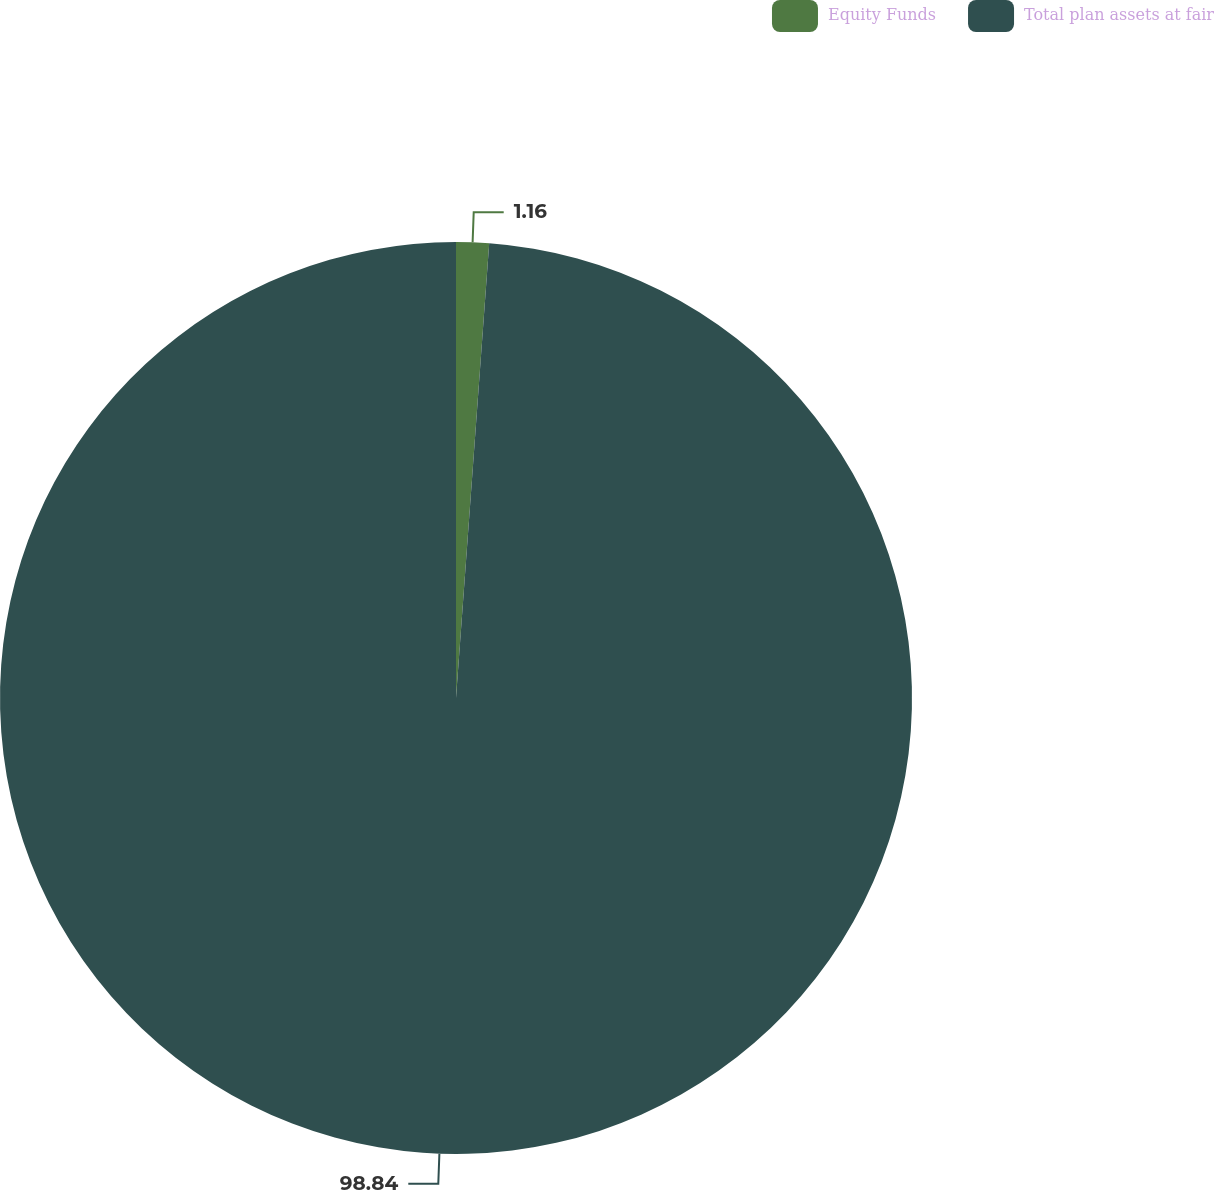Convert chart to OTSL. <chart><loc_0><loc_0><loc_500><loc_500><pie_chart><fcel>Equity Funds<fcel>Total plan assets at fair<nl><fcel>1.16%<fcel>98.84%<nl></chart> 